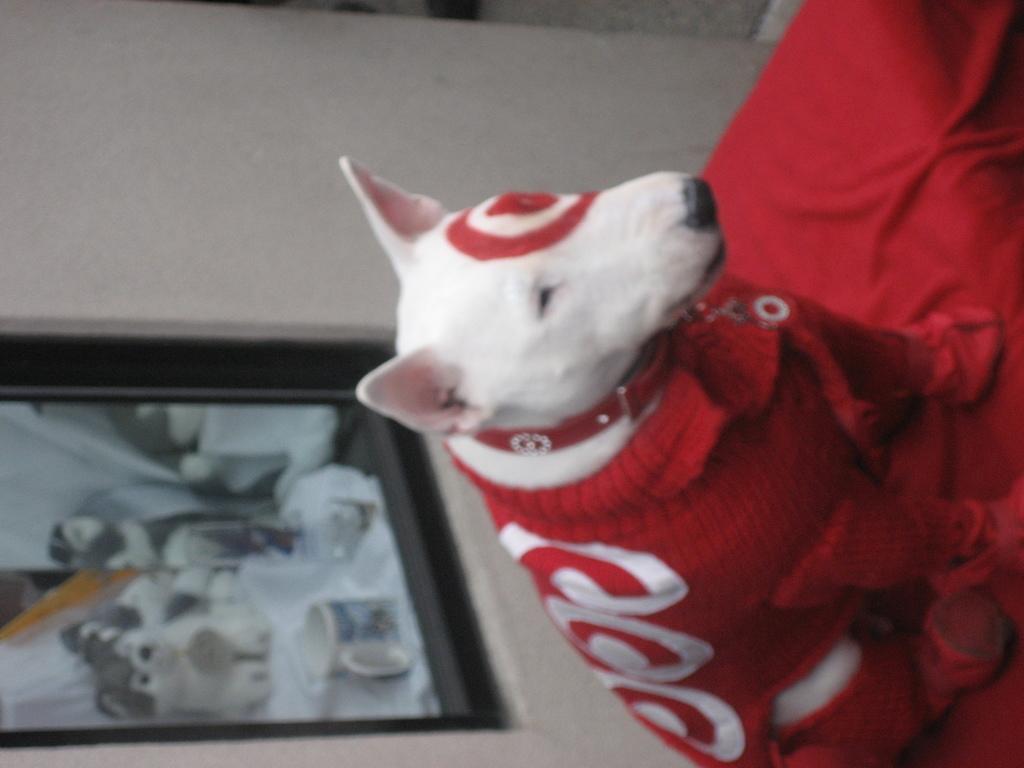In one or two sentences, can you explain what this image depicts? In this image I can see a dog which is white in color wearing red and white colored dress is sitting on the red colored object. In the background I can see the white colored wall and a photo frame attached to the wall. 